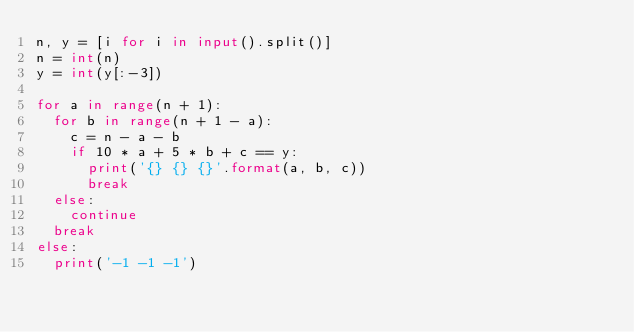<code> <loc_0><loc_0><loc_500><loc_500><_Python_>n, y = [i for i in input().split()]
n = int(n)
y = int(y[:-3])

for a in range(n + 1):
  for b in range(n + 1 - a):
    c = n - a - b
    if 10 * a + 5 * b + c == y:
      print('{} {} {}'.format(a, b, c))
      break
  else:
    continue
  break
else:
  print('-1 -1 -1')
</code> 